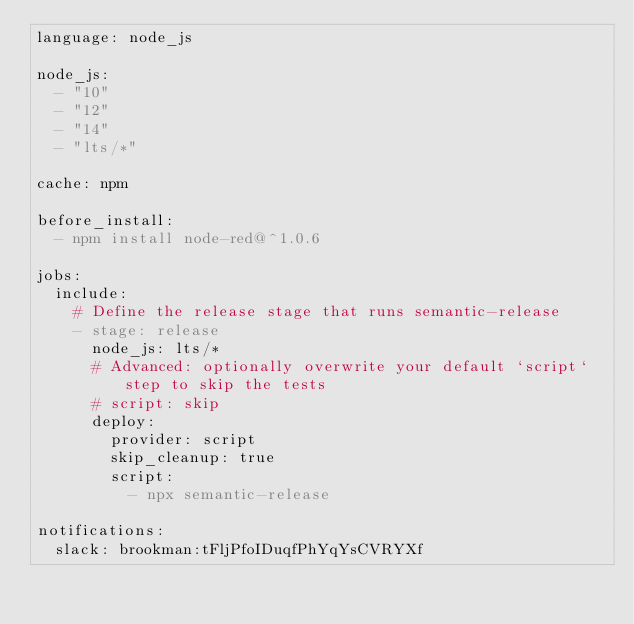<code> <loc_0><loc_0><loc_500><loc_500><_YAML_>language: node_js

node_js:
  - "10"
  - "12"
  - "14"
  - "lts/*"

cache: npm

before_install:
  - npm install node-red@^1.0.6

jobs:
  include:
    # Define the release stage that runs semantic-release
    - stage: release
      node_js: lts/*
      # Advanced: optionally overwrite your default `script` step to skip the tests
      # script: skip
      deploy:
        provider: script
        skip_cleanup: true
        script:
          - npx semantic-release

notifications:
  slack: brookman:tFljPfoIDuqfPhYqYsCVRYXf</code> 